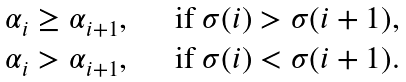<formula> <loc_0><loc_0><loc_500><loc_500>\begin{array} { l l } \alpha _ { i } \geq \alpha _ { i + 1 } , & \quad \text {if } \sigma ( i ) > \sigma ( i + 1 ) , \\ \alpha _ { i } > \alpha _ { i + 1 } , & \quad \text {if } \sigma ( i ) < \sigma ( i + 1 ) . \end{array}</formula> 